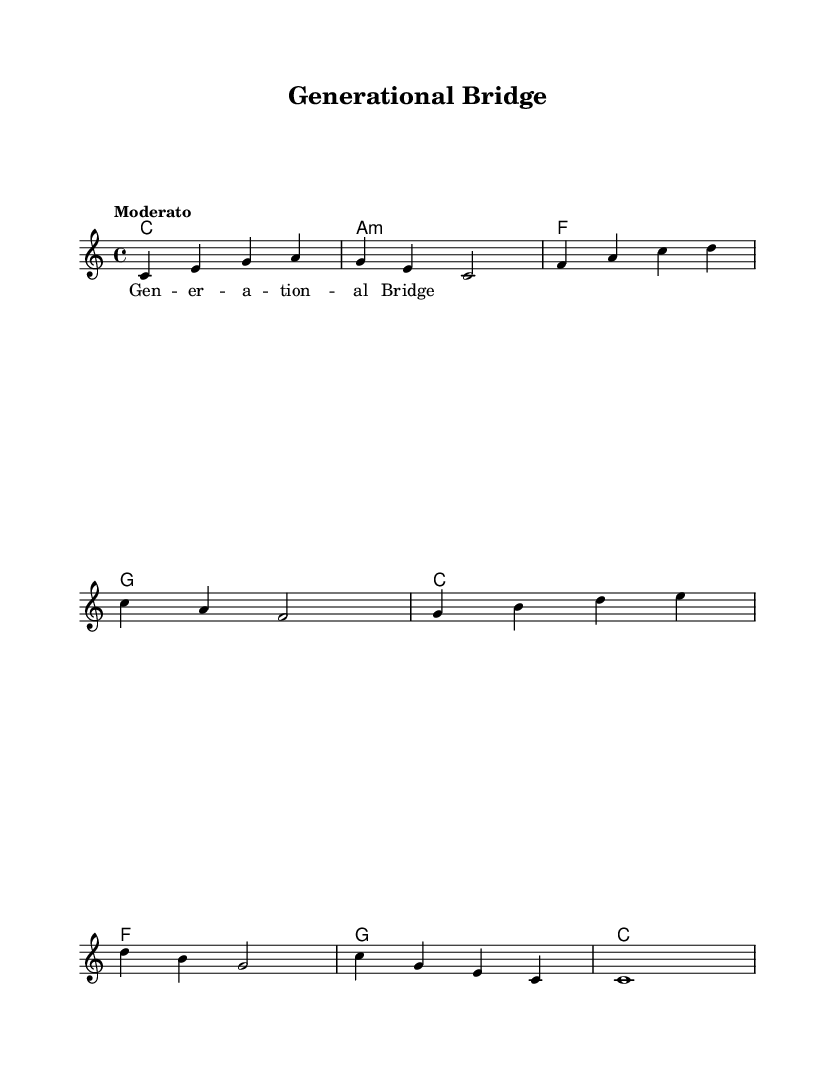What is the key signature of this music? The key signature of the piece is C major, which contains no sharps or flats. This can be determined by looking for the absence of any accidentals on the staff.
Answer: C major What is the time signature of the piece? The time signature indicated in the music is 4/4, which can be found written at the beginning of the score. This indicates that there are four beats per measure.
Answer: 4/4 What is the tempo marking of this piece? The tempo marking is "Moderato", which describes a moderate speed. This marking is typically placed above the staff at the beginning of the music.
Answer: Moderato How many measures are there in the score? There are eight measures in the score, which can be counted from the beginning to the end of the melody line presented. Each group of musical notes separated by vertical lines represents one measure.
Answer: Eight Which chord is played at the beginning of the music? The chord played at the beginning is C major. This can be seen in the chord notation at the start of the score, where the chord symbol corresponds to the first measure.
Answer: C What is the last note of the melody? The last note of the melody is a C. This is identifiable by looking at the final note on the staff in the melody section, which is notated directly before the end of the staff.
Answer: C What type of music is represented in this score? This score represents a classic Motown hit, which is characterized by its soulful style and bridging generational gaps through its engaging melodies. The title "Generational Bridge" reflects this theme.
Answer: Classic Motown 